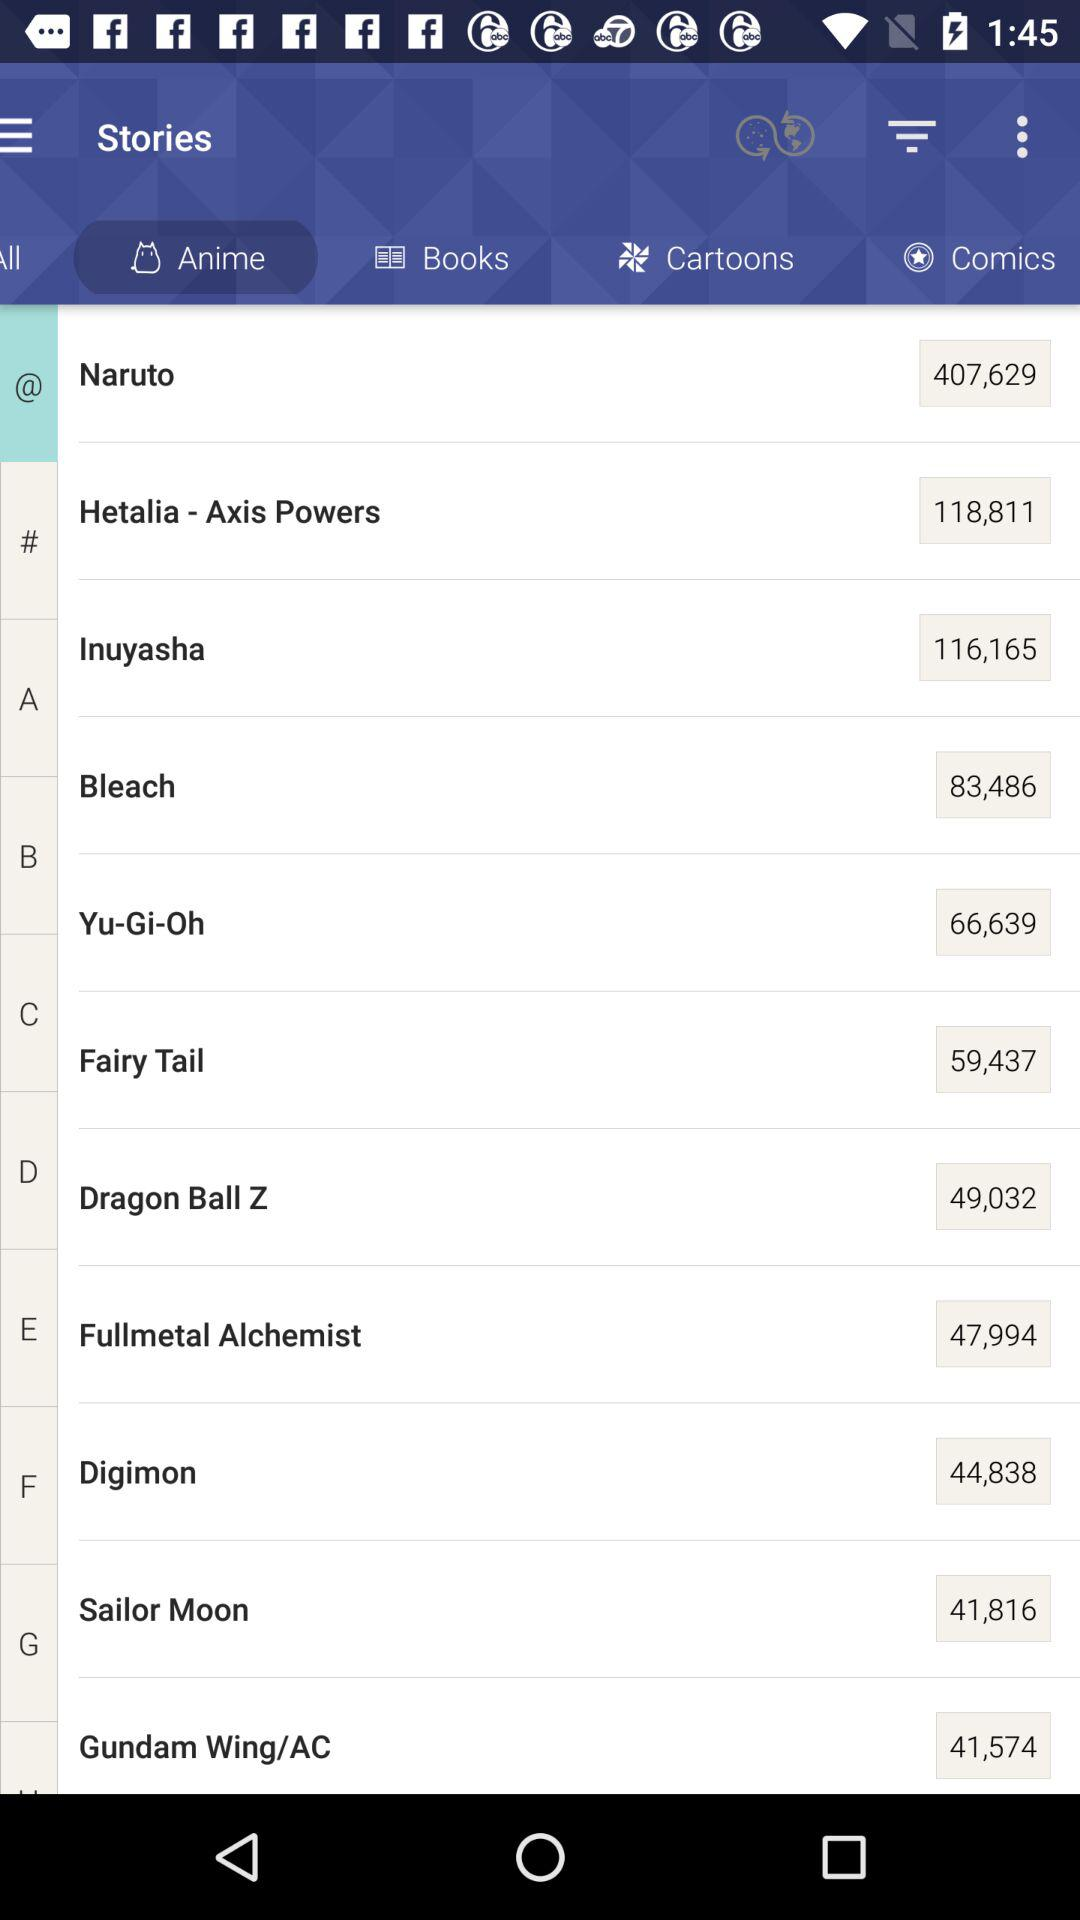What is the count in bleach? The count in bleach is 83,486. 